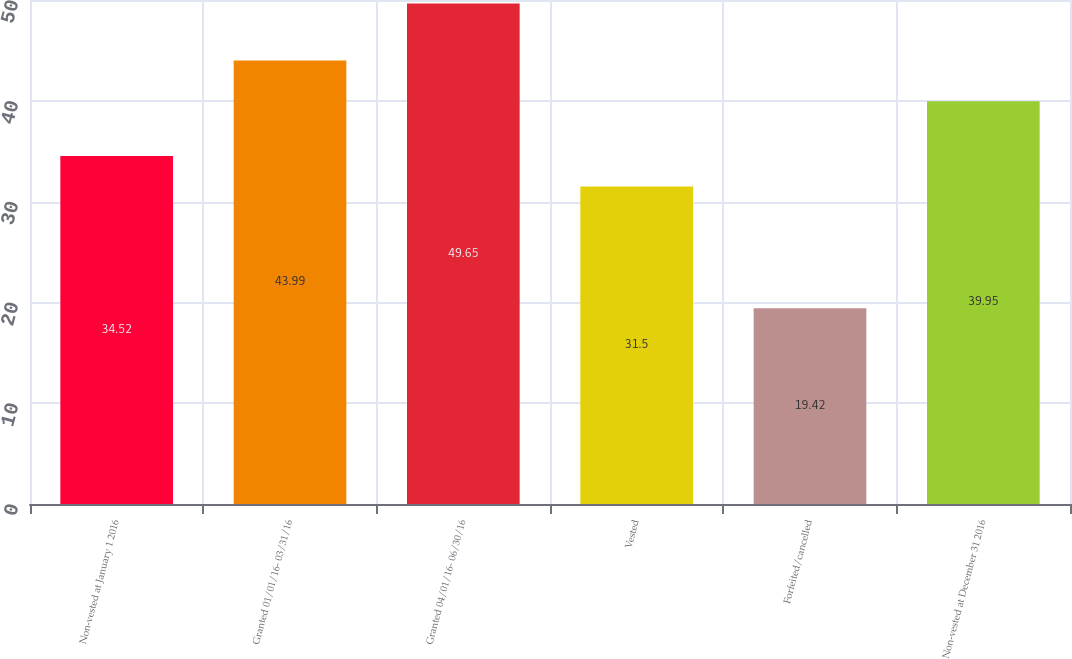Convert chart. <chart><loc_0><loc_0><loc_500><loc_500><bar_chart><fcel>Non-vested at January 1 2016<fcel>Granted 01/01/16- 03/31/16<fcel>Granted 04/01/16- 06/30/16<fcel>Vested<fcel>Forfeited/cancelled<fcel>Non-vested at December 31 2016<nl><fcel>34.52<fcel>43.99<fcel>49.65<fcel>31.5<fcel>19.42<fcel>39.95<nl></chart> 